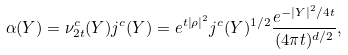<formula> <loc_0><loc_0><loc_500><loc_500>\alpha ( Y ) = \nu _ { 2 t } ^ { c } ( Y ) j ^ { c } ( Y ) = e ^ { t \left | \rho \right | ^ { 2 } } j ^ { c } ( Y ) ^ { 1 / 2 } \frac { e ^ { - \left | Y \right | ^ { 2 } / 4 t } } { ( 4 \pi t ) ^ { d / 2 } } ,</formula> 